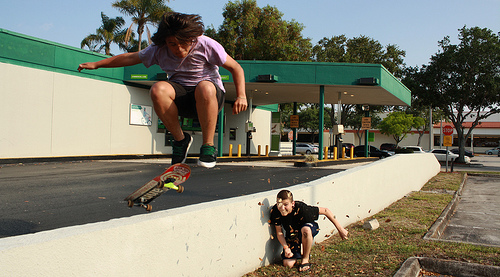Can you detail the surrounding architecture and its significance to the setting? The background features a typical suburban commercial building with a distinctive green awning, likely a small business. This setting places the action within a community-centered area, possibly frequented by locals and illustrating a slice of everyday life. 